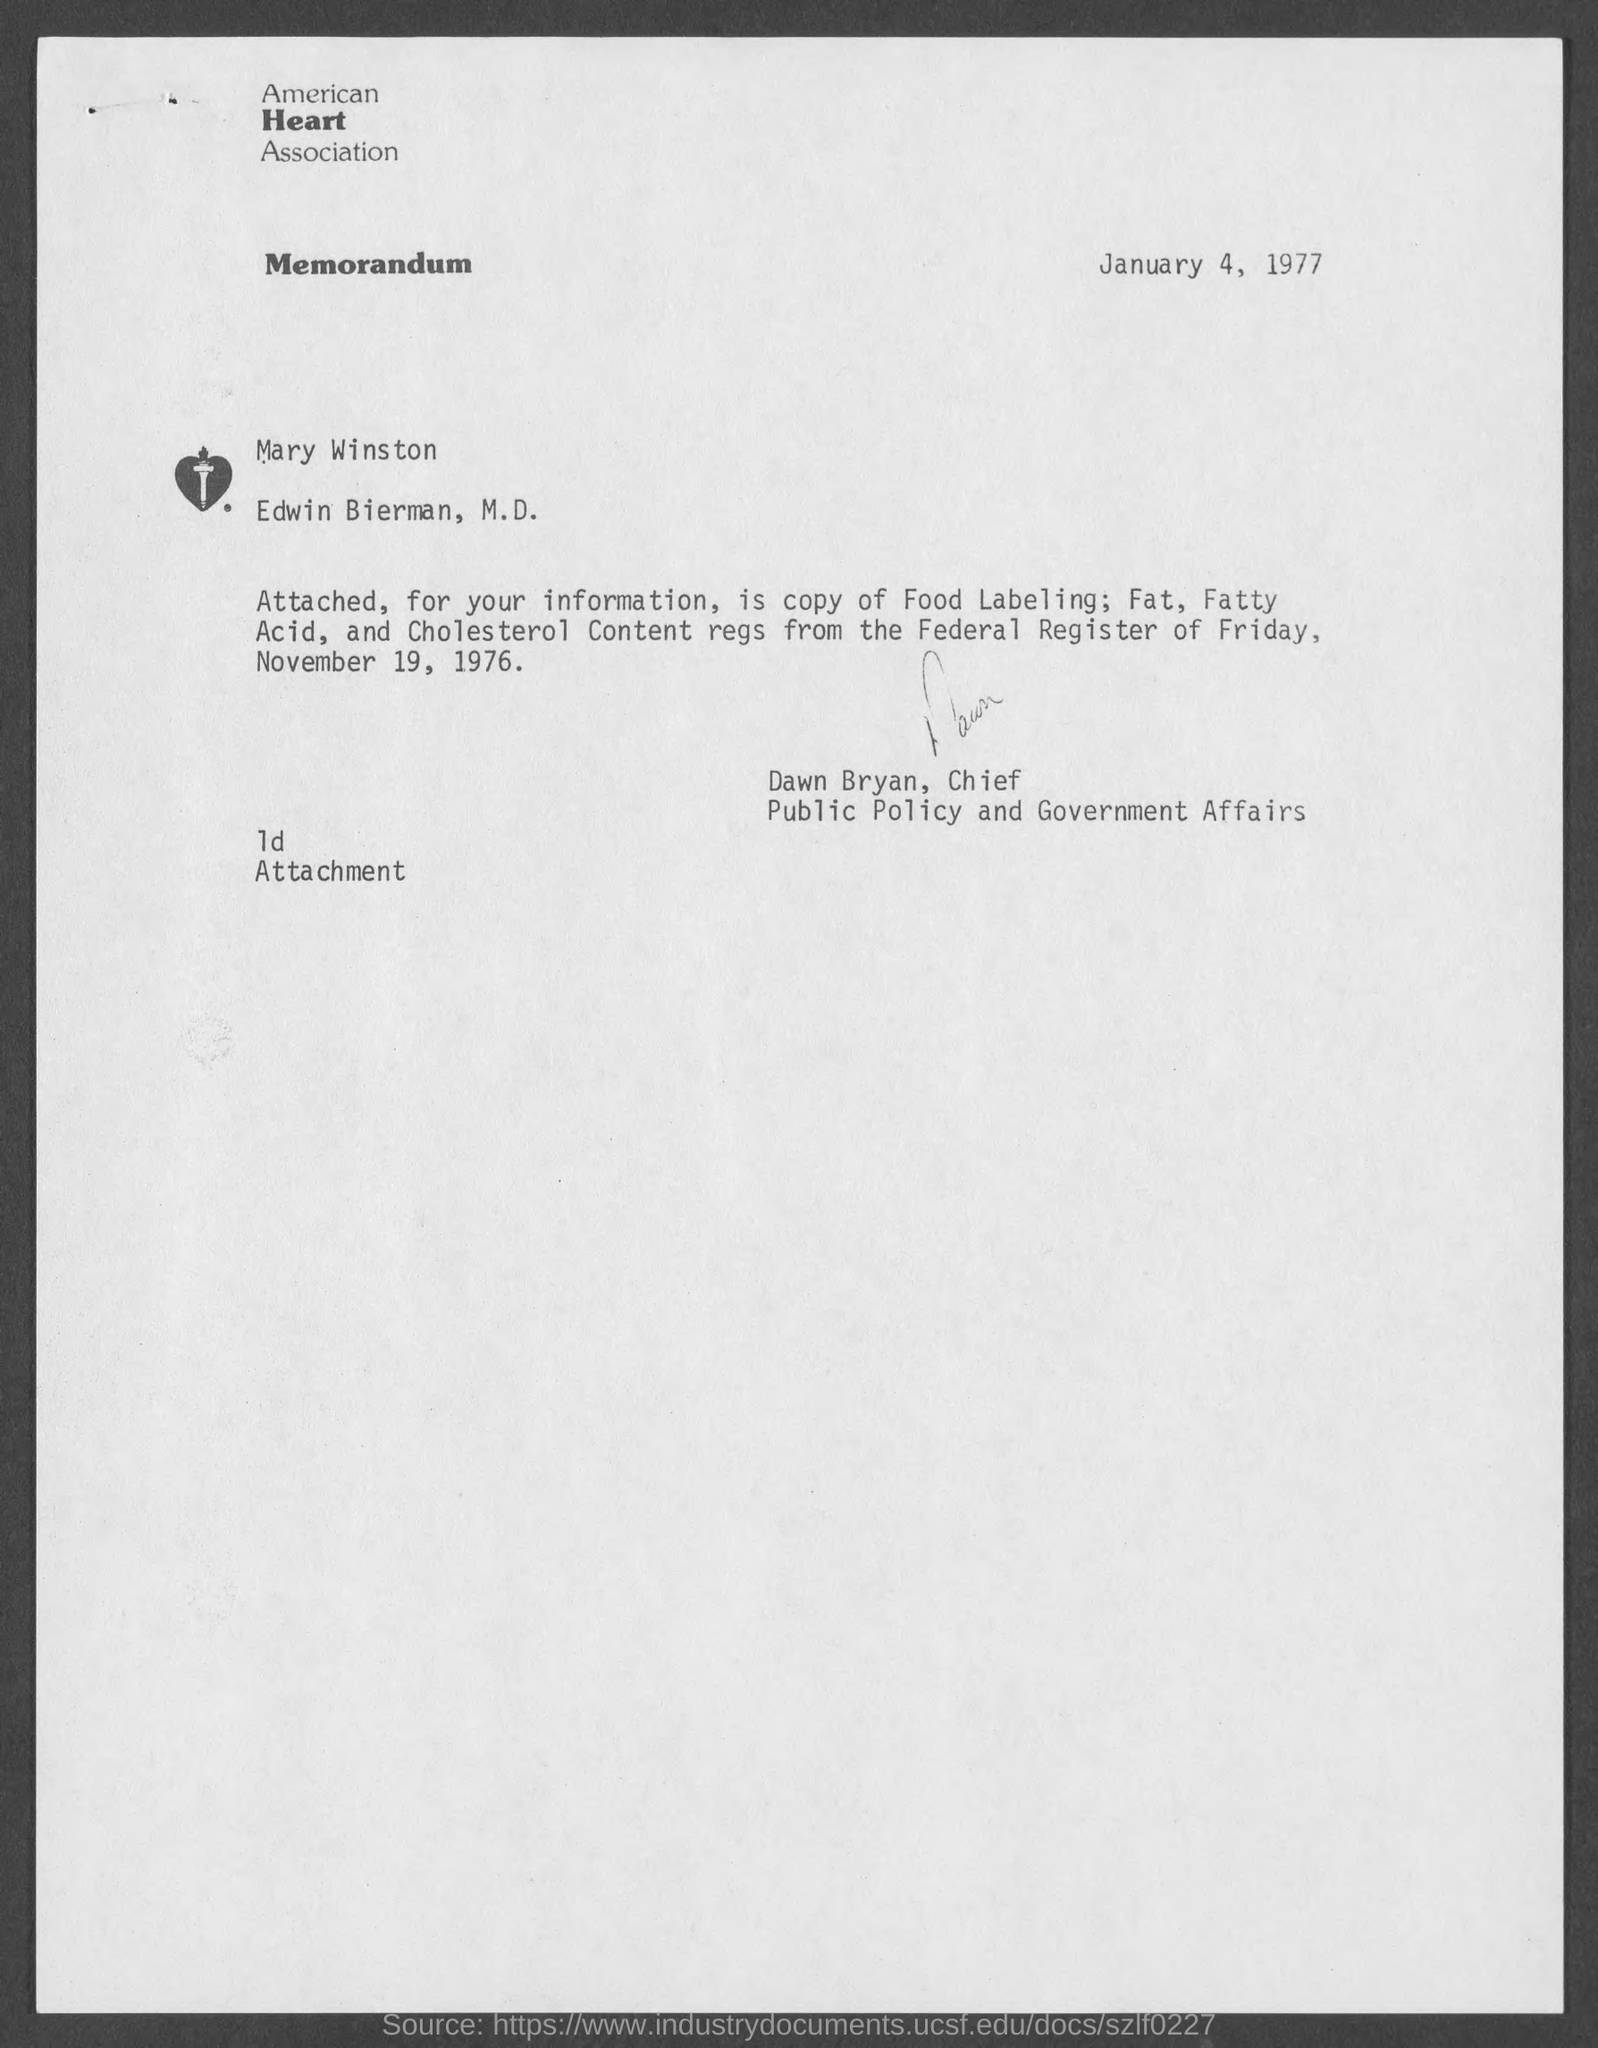When is the memorandum dated?
Offer a very short reply. January 4 , 1977. What is the name of the heart association ?
Give a very brief answer. American Heart Association. 